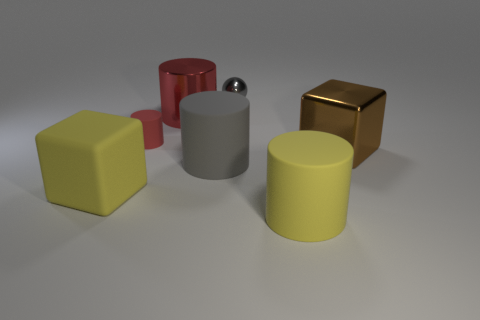Subtract all big gray cylinders. How many cylinders are left? 3 Subtract all red cylinders. How many cylinders are left? 2 Subtract all balls. How many objects are left? 6 Add 1 large cylinders. How many objects exist? 8 Subtract 2 cubes. How many cubes are left? 0 Add 1 big yellow cubes. How many big yellow cubes exist? 2 Subtract 0 blue cylinders. How many objects are left? 7 Subtract all purple cubes. Subtract all green spheres. How many cubes are left? 2 Subtract all purple cubes. How many gray cylinders are left? 1 Subtract all big metal cubes. Subtract all red objects. How many objects are left? 4 